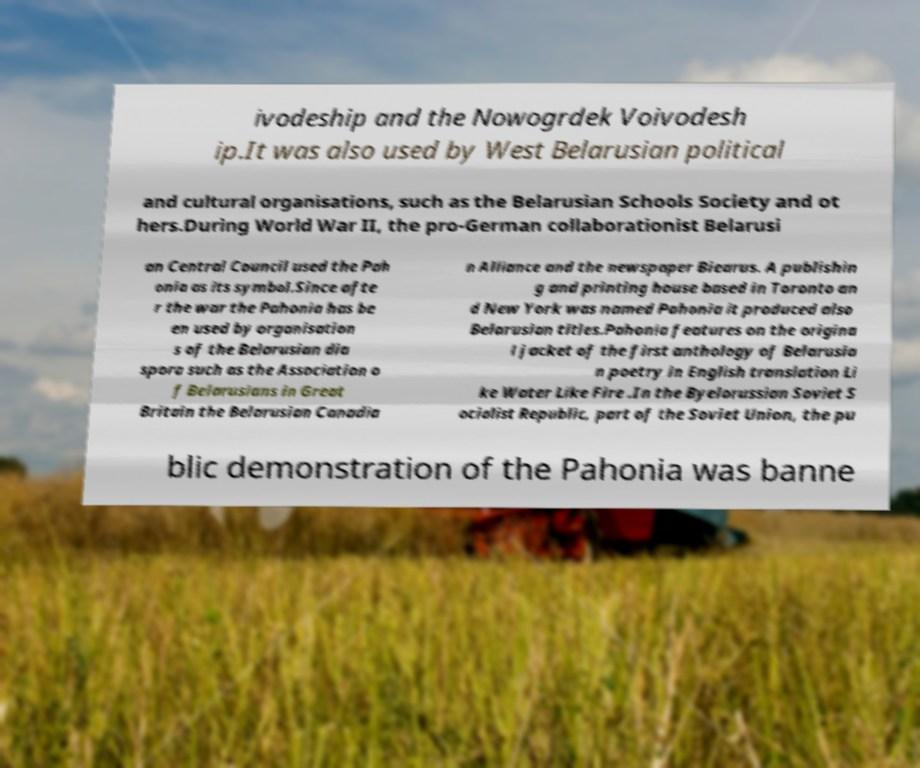Please read and relay the text visible in this image. What does it say? ivodeship and the Nowogrdek Voivodesh ip.It was also used by West Belarusian political and cultural organisations, such as the Belarusian Schools Society and ot hers.During World War II, the pro-German collaborationist Belarusi an Central Council used the Pah onia as its symbol.Since afte r the war the Pahonia has be en used by organisation s of the Belarusian dia spora such as the Association o f Belarusians in Great Britain the Belarusian Canadia n Alliance and the newspaper Biearus. A publishin g and printing house based in Toronto an d New York was named Pahonia it produced also Belarusian titles.Pahonia features on the origina l jacket of the first anthology of Belarusia n poetry in English translation Li ke Water Like Fire .In the Byelorussian Soviet S ocialist Republic, part of the Soviet Union, the pu blic demonstration of the Pahonia was banne 